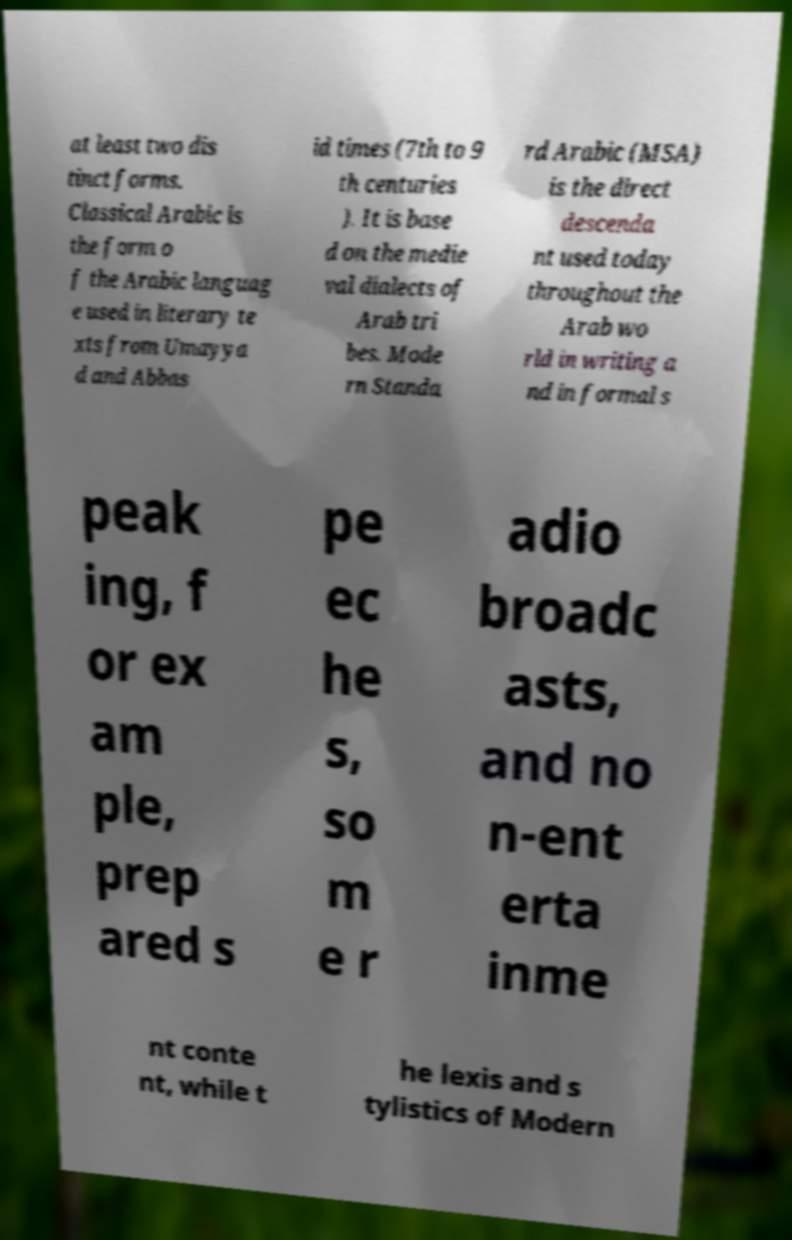There's text embedded in this image that I need extracted. Can you transcribe it verbatim? at least two dis tinct forms. Classical Arabic is the form o f the Arabic languag e used in literary te xts from Umayya d and Abbas id times (7th to 9 th centuries ). It is base d on the medie val dialects of Arab tri bes. Mode rn Standa rd Arabic (MSA) is the direct descenda nt used today throughout the Arab wo rld in writing a nd in formal s peak ing, f or ex am ple, prep ared s pe ec he s, so m e r adio broadc asts, and no n-ent erta inme nt conte nt, while t he lexis and s tylistics of Modern 